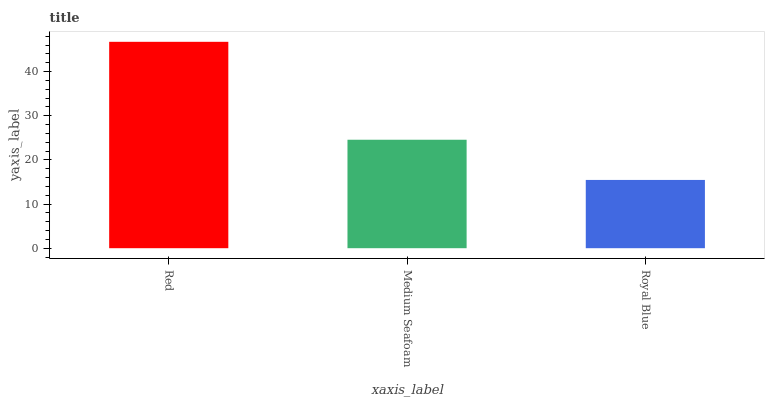Is Royal Blue the minimum?
Answer yes or no. Yes. Is Red the maximum?
Answer yes or no. Yes. Is Medium Seafoam the minimum?
Answer yes or no. No. Is Medium Seafoam the maximum?
Answer yes or no. No. Is Red greater than Medium Seafoam?
Answer yes or no. Yes. Is Medium Seafoam less than Red?
Answer yes or no. Yes. Is Medium Seafoam greater than Red?
Answer yes or no. No. Is Red less than Medium Seafoam?
Answer yes or no. No. Is Medium Seafoam the high median?
Answer yes or no. Yes. Is Medium Seafoam the low median?
Answer yes or no. Yes. Is Red the high median?
Answer yes or no. No. Is Red the low median?
Answer yes or no. No. 